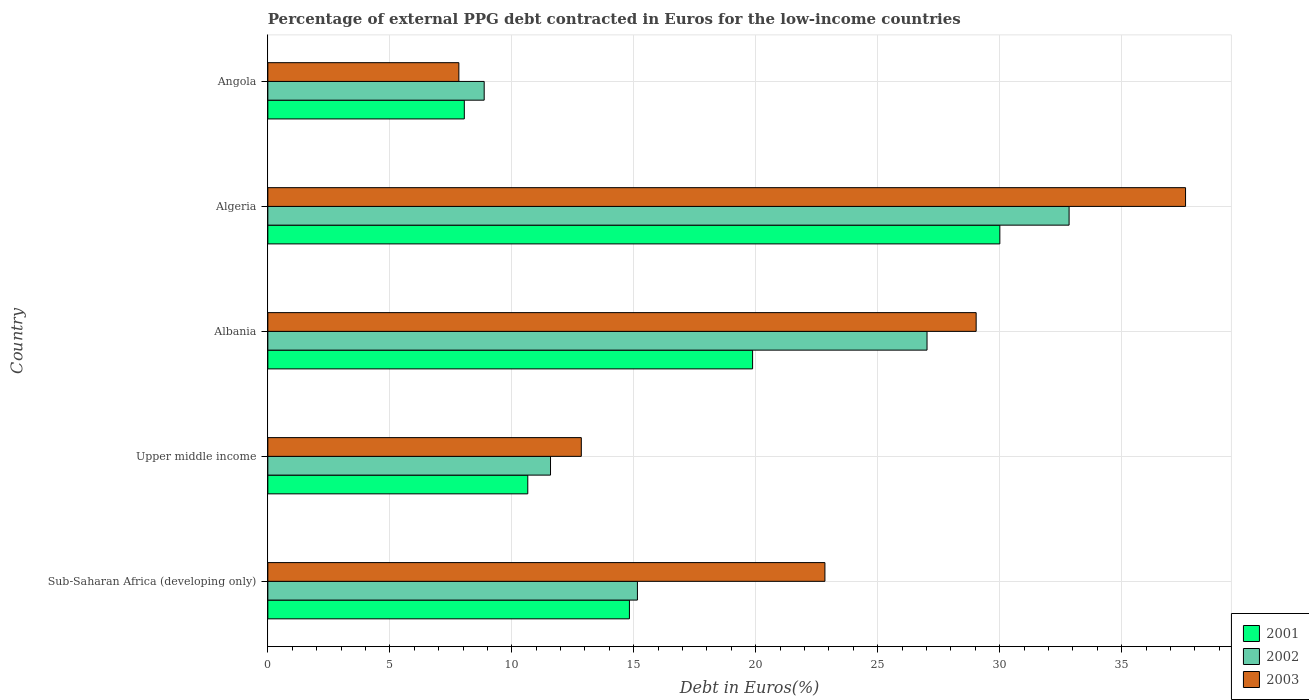Are the number of bars on each tick of the Y-axis equal?
Make the answer very short. Yes. How many bars are there on the 1st tick from the top?
Provide a short and direct response. 3. How many bars are there on the 5th tick from the bottom?
Keep it short and to the point. 3. What is the label of the 4th group of bars from the top?
Your answer should be very brief. Upper middle income. In how many cases, is the number of bars for a given country not equal to the number of legend labels?
Your answer should be very brief. 0. What is the percentage of external PPG debt contracted in Euros in 2003 in Algeria?
Provide a succinct answer. 37.62. Across all countries, what is the maximum percentage of external PPG debt contracted in Euros in 2001?
Keep it short and to the point. 30.01. Across all countries, what is the minimum percentage of external PPG debt contracted in Euros in 2002?
Provide a succinct answer. 8.87. In which country was the percentage of external PPG debt contracted in Euros in 2001 maximum?
Give a very brief answer. Algeria. In which country was the percentage of external PPG debt contracted in Euros in 2003 minimum?
Your answer should be compact. Angola. What is the total percentage of external PPG debt contracted in Euros in 2003 in the graph?
Provide a succinct answer. 110.17. What is the difference between the percentage of external PPG debt contracted in Euros in 2003 in Algeria and that in Angola?
Your answer should be compact. 29.79. What is the difference between the percentage of external PPG debt contracted in Euros in 2002 in Albania and the percentage of external PPG debt contracted in Euros in 2001 in Sub-Saharan Africa (developing only)?
Keep it short and to the point. 12.2. What is the average percentage of external PPG debt contracted in Euros in 2003 per country?
Provide a short and direct response. 22.03. What is the difference between the percentage of external PPG debt contracted in Euros in 2003 and percentage of external PPG debt contracted in Euros in 2002 in Albania?
Your response must be concise. 2.01. In how many countries, is the percentage of external PPG debt contracted in Euros in 2003 greater than 12 %?
Your answer should be compact. 4. What is the ratio of the percentage of external PPG debt contracted in Euros in 2001 in Algeria to that in Upper middle income?
Offer a very short reply. 2.82. Is the difference between the percentage of external PPG debt contracted in Euros in 2003 in Albania and Upper middle income greater than the difference between the percentage of external PPG debt contracted in Euros in 2002 in Albania and Upper middle income?
Make the answer very short. Yes. What is the difference between the highest and the second highest percentage of external PPG debt contracted in Euros in 2002?
Offer a very short reply. 5.82. What is the difference between the highest and the lowest percentage of external PPG debt contracted in Euros in 2003?
Offer a terse response. 29.79. In how many countries, is the percentage of external PPG debt contracted in Euros in 2002 greater than the average percentage of external PPG debt contracted in Euros in 2002 taken over all countries?
Make the answer very short. 2. What does the 3rd bar from the top in Angola represents?
Make the answer very short. 2001. What does the 1st bar from the bottom in Angola represents?
Keep it short and to the point. 2001. Is it the case that in every country, the sum of the percentage of external PPG debt contracted in Euros in 2003 and percentage of external PPG debt contracted in Euros in 2001 is greater than the percentage of external PPG debt contracted in Euros in 2002?
Offer a terse response. Yes. How many bars are there?
Ensure brevity in your answer.  15. Are all the bars in the graph horizontal?
Keep it short and to the point. Yes. How many countries are there in the graph?
Your answer should be compact. 5. Does the graph contain grids?
Your answer should be very brief. Yes. Where does the legend appear in the graph?
Your response must be concise. Bottom right. What is the title of the graph?
Make the answer very short. Percentage of external PPG debt contracted in Euros for the low-income countries. Does "1986" appear as one of the legend labels in the graph?
Your answer should be very brief. No. What is the label or title of the X-axis?
Provide a succinct answer. Debt in Euros(%). What is the Debt in Euros(%) in 2001 in Sub-Saharan Africa (developing only)?
Ensure brevity in your answer.  14.82. What is the Debt in Euros(%) of 2002 in Sub-Saharan Africa (developing only)?
Provide a short and direct response. 15.15. What is the Debt in Euros(%) of 2003 in Sub-Saharan Africa (developing only)?
Provide a succinct answer. 22.84. What is the Debt in Euros(%) of 2001 in Upper middle income?
Offer a very short reply. 10.66. What is the Debt in Euros(%) of 2002 in Upper middle income?
Make the answer very short. 11.59. What is the Debt in Euros(%) in 2003 in Upper middle income?
Provide a short and direct response. 12.85. What is the Debt in Euros(%) in 2001 in Albania?
Your response must be concise. 19.87. What is the Debt in Euros(%) in 2002 in Albania?
Provide a succinct answer. 27.02. What is the Debt in Euros(%) of 2003 in Albania?
Offer a terse response. 29.04. What is the Debt in Euros(%) of 2001 in Algeria?
Your answer should be compact. 30.01. What is the Debt in Euros(%) in 2002 in Algeria?
Ensure brevity in your answer.  32.85. What is the Debt in Euros(%) of 2003 in Algeria?
Offer a terse response. 37.62. What is the Debt in Euros(%) in 2001 in Angola?
Keep it short and to the point. 8.05. What is the Debt in Euros(%) in 2002 in Angola?
Your answer should be very brief. 8.87. What is the Debt in Euros(%) of 2003 in Angola?
Offer a very short reply. 7.83. Across all countries, what is the maximum Debt in Euros(%) in 2001?
Offer a very short reply. 30.01. Across all countries, what is the maximum Debt in Euros(%) of 2002?
Provide a succinct answer. 32.85. Across all countries, what is the maximum Debt in Euros(%) of 2003?
Your answer should be compact. 37.62. Across all countries, what is the minimum Debt in Euros(%) of 2001?
Provide a succinct answer. 8.05. Across all countries, what is the minimum Debt in Euros(%) in 2002?
Keep it short and to the point. 8.87. Across all countries, what is the minimum Debt in Euros(%) of 2003?
Your response must be concise. 7.83. What is the total Debt in Euros(%) of 2001 in the graph?
Your answer should be compact. 83.41. What is the total Debt in Euros(%) of 2002 in the graph?
Keep it short and to the point. 95.47. What is the total Debt in Euros(%) in 2003 in the graph?
Provide a short and direct response. 110.17. What is the difference between the Debt in Euros(%) of 2001 in Sub-Saharan Africa (developing only) and that in Upper middle income?
Provide a succinct answer. 4.17. What is the difference between the Debt in Euros(%) in 2002 in Sub-Saharan Africa (developing only) and that in Upper middle income?
Provide a succinct answer. 3.56. What is the difference between the Debt in Euros(%) in 2003 in Sub-Saharan Africa (developing only) and that in Upper middle income?
Provide a succinct answer. 9.99. What is the difference between the Debt in Euros(%) of 2001 in Sub-Saharan Africa (developing only) and that in Albania?
Offer a terse response. -5.05. What is the difference between the Debt in Euros(%) of 2002 in Sub-Saharan Africa (developing only) and that in Albania?
Give a very brief answer. -11.87. What is the difference between the Debt in Euros(%) in 2003 in Sub-Saharan Africa (developing only) and that in Albania?
Provide a succinct answer. -6.2. What is the difference between the Debt in Euros(%) of 2001 in Sub-Saharan Africa (developing only) and that in Algeria?
Keep it short and to the point. -15.18. What is the difference between the Debt in Euros(%) of 2002 in Sub-Saharan Africa (developing only) and that in Algeria?
Ensure brevity in your answer.  -17.7. What is the difference between the Debt in Euros(%) in 2003 in Sub-Saharan Africa (developing only) and that in Algeria?
Ensure brevity in your answer.  -14.78. What is the difference between the Debt in Euros(%) of 2001 in Sub-Saharan Africa (developing only) and that in Angola?
Keep it short and to the point. 6.77. What is the difference between the Debt in Euros(%) in 2002 in Sub-Saharan Africa (developing only) and that in Angola?
Your answer should be very brief. 6.28. What is the difference between the Debt in Euros(%) in 2003 in Sub-Saharan Africa (developing only) and that in Angola?
Your answer should be very brief. 15.01. What is the difference between the Debt in Euros(%) in 2001 in Upper middle income and that in Albania?
Provide a short and direct response. -9.22. What is the difference between the Debt in Euros(%) in 2002 in Upper middle income and that in Albania?
Offer a terse response. -15.43. What is the difference between the Debt in Euros(%) in 2003 in Upper middle income and that in Albania?
Provide a succinct answer. -16.19. What is the difference between the Debt in Euros(%) of 2001 in Upper middle income and that in Algeria?
Provide a succinct answer. -19.35. What is the difference between the Debt in Euros(%) in 2002 in Upper middle income and that in Algeria?
Keep it short and to the point. -21.26. What is the difference between the Debt in Euros(%) of 2003 in Upper middle income and that in Algeria?
Provide a succinct answer. -24.77. What is the difference between the Debt in Euros(%) in 2001 in Upper middle income and that in Angola?
Your answer should be compact. 2.6. What is the difference between the Debt in Euros(%) of 2002 in Upper middle income and that in Angola?
Offer a very short reply. 2.72. What is the difference between the Debt in Euros(%) of 2003 in Upper middle income and that in Angola?
Make the answer very short. 5.02. What is the difference between the Debt in Euros(%) in 2001 in Albania and that in Algeria?
Your answer should be very brief. -10.14. What is the difference between the Debt in Euros(%) in 2002 in Albania and that in Algeria?
Provide a succinct answer. -5.82. What is the difference between the Debt in Euros(%) in 2003 in Albania and that in Algeria?
Your response must be concise. -8.58. What is the difference between the Debt in Euros(%) of 2001 in Albania and that in Angola?
Provide a short and direct response. 11.82. What is the difference between the Debt in Euros(%) of 2002 in Albania and that in Angola?
Provide a short and direct response. 18.15. What is the difference between the Debt in Euros(%) in 2003 in Albania and that in Angola?
Provide a succinct answer. 21.21. What is the difference between the Debt in Euros(%) of 2001 in Algeria and that in Angola?
Give a very brief answer. 21.95. What is the difference between the Debt in Euros(%) in 2002 in Algeria and that in Angola?
Give a very brief answer. 23.98. What is the difference between the Debt in Euros(%) of 2003 in Algeria and that in Angola?
Offer a terse response. 29.79. What is the difference between the Debt in Euros(%) of 2001 in Sub-Saharan Africa (developing only) and the Debt in Euros(%) of 2002 in Upper middle income?
Keep it short and to the point. 3.23. What is the difference between the Debt in Euros(%) in 2001 in Sub-Saharan Africa (developing only) and the Debt in Euros(%) in 2003 in Upper middle income?
Make the answer very short. 1.97. What is the difference between the Debt in Euros(%) in 2002 in Sub-Saharan Africa (developing only) and the Debt in Euros(%) in 2003 in Upper middle income?
Your answer should be very brief. 2.3. What is the difference between the Debt in Euros(%) in 2001 in Sub-Saharan Africa (developing only) and the Debt in Euros(%) in 2002 in Albania?
Keep it short and to the point. -12.2. What is the difference between the Debt in Euros(%) of 2001 in Sub-Saharan Africa (developing only) and the Debt in Euros(%) of 2003 in Albania?
Your response must be concise. -14.21. What is the difference between the Debt in Euros(%) of 2002 in Sub-Saharan Africa (developing only) and the Debt in Euros(%) of 2003 in Albania?
Provide a short and direct response. -13.89. What is the difference between the Debt in Euros(%) in 2001 in Sub-Saharan Africa (developing only) and the Debt in Euros(%) in 2002 in Algeria?
Offer a terse response. -18.02. What is the difference between the Debt in Euros(%) in 2001 in Sub-Saharan Africa (developing only) and the Debt in Euros(%) in 2003 in Algeria?
Provide a succinct answer. -22.8. What is the difference between the Debt in Euros(%) of 2002 in Sub-Saharan Africa (developing only) and the Debt in Euros(%) of 2003 in Algeria?
Give a very brief answer. -22.47. What is the difference between the Debt in Euros(%) in 2001 in Sub-Saharan Africa (developing only) and the Debt in Euros(%) in 2002 in Angola?
Your answer should be compact. 5.95. What is the difference between the Debt in Euros(%) in 2001 in Sub-Saharan Africa (developing only) and the Debt in Euros(%) in 2003 in Angola?
Ensure brevity in your answer.  6.99. What is the difference between the Debt in Euros(%) in 2002 in Sub-Saharan Africa (developing only) and the Debt in Euros(%) in 2003 in Angola?
Provide a succinct answer. 7.32. What is the difference between the Debt in Euros(%) of 2001 in Upper middle income and the Debt in Euros(%) of 2002 in Albania?
Ensure brevity in your answer.  -16.37. What is the difference between the Debt in Euros(%) of 2001 in Upper middle income and the Debt in Euros(%) of 2003 in Albania?
Your response must be concise. -18.38. What is the difference between the Debt in Euros(%) in 2002 in Upper middle income and the Debt in Euros(%) in 2003 in Albania?
Provide a succinct answer. -17.45. What is the difference between the Debt in Euros(%) of 2001 in Upper middle income and the Debt in Euros(%) of 2002 in Algeria?
Offer a very short reply. -22.19. What is the difference between the Debt in Euros(%) in 2001 in Upper middle income and the Debt in Euros(%) in 2003 in Algeria?
Your answer should be very brief. -26.96. What is the difference between the Debt in Euros(%) of 2002 in Upper middle income and the Debt in Euros(%) of 2003 in Algeria?
Provide a short and direct response. -26.03. What is the difference between the Debt in Euros(%) of 2001 in Upper middle income and the Debt in Euros(%) of 2002 in Angola?
Provide a succinct answer. 1.79. What is the difference between the Debt in Euros(%) in 2001 in Upper middle income and the Debt in Euros(%) in 2003 in Angola?
Keep it short and to the point. 2.83. What is the difference between the Debt in Euros(%) of 2002 in Upper middle income and the Debt in Euros(%) of 2003 in Angola?
Provide a short and direct response. 3.76. What is the difference between the Debt in Euros(%) in 2001 in Albania and the Debt in Euros(%) in 2002 in Algeria?
Make the answer very short. -12.97. What is the difference between the Debt in Euros(%) in 2001 in Albania and the Debt in Euros(%) in 2003 in Algeria?
Make the answer very short. -17.75. What is the difference between the Debt in Euros(%) of 2002 in Albania and the Debt in Euros(%) of 2003 in Algeria?
Offer a terse response. -10.6. What is the difference between the Debt in Euros(%) in 2001 in Albania and the Debt in Euros(%) in 2002 in Angola?
Offer a terse response. 11. What is the difference between the Debt in Euros(%) in 2001 in Albania and the Debt in Euros(%) in 2003 in Angola?
Give a very brief answer. 12.04. What is the difference between the Debt in Euros(%) in 2002 in Albania and the Debt in Euros(%) in 2003 in Angola?
Your answer should be compact. 19.19. What is the difference between the Debt in Euros(%) in 2001 in Algeria and the Debt in Euros(%) in 2002 in Angola?
Your response must be concise. 21.14. What is the difference between the Debt in Euros(%) in 2001 in Algeria and the Debt in Euros(%) in 2003 in Angola?
Your answer should be compact. 22.18. What is the difference between the Debt in Euros(%) of 2002 in Algeria and the Debt in Euros(%) of 2003 in Angola?
Offer a terse response. 25.02. What is the average Debt in Euros(%) of 2001 per country?
Your response must be concise. 16.68. What is the average Debt in Euros(%) in 2002 per country?
Your response must be concise. 19.09. What is the average Debt in Euros(%) in 2003 per country?
Offer a terse response. 22.03. What is the difference between the Debt in Euros(%) of 2001 and Debt in Euros(%) of 2002 in Sub-Saharan Africa (developing only)?
Keep it short and to the point. -0.33. What is the difference between the Debt in Euros(%) of 2001 and Debt in Euros(%) of 2003 in Sub-Saharan Africa (developing only)?
Make the answer very short. -8.01. What is the difference between the Debt in Euros(%) of 2002 and Debt in Euros(%) of 2003 in Sub-Saharan Africa (developing only)?
Ensure brevity in your answer.  -7.69. What is the difference between the Debt in Euros(%) in 2001 and Debt in Euros(%) in 2002 in Upper middle income?
Give a very brief answer. -0.93. What is the difference between the Debt in Euros(%) of 2001 and Debt in Euros(%) of 2003 in Upper middle income?
Offer a terse response. -2.19. What is the difference between the Debt in Euros(%) in 2002 and Debt in Euros(%) in 2003 in Upper middle income?
Your answer should be compact. -1.26. What is the difference between the Debt in Euros(%) of 2001 and Debt in Euros(%) of 2002 in Albania?
Offer a terse response. -7.15. What is the difference between the Debt in Euros(%) in 2001 and Debt in Euros(%) in 2003 in Albania?
Keep it short and to the point. -9.16. What is the difference between the Debt in Euros(%) in 2002 and Debt in Euros(%) in 2003 in Albania?
Your answer should be compact. -2.01. What is the difference between the Debt in Euros(%) in 2001 and Debt in Euros(%) in 2002 in Algeria?
Make the answer very short. -2.84. What is the difference between the Debt in Euros(%) in 2001 and Debt in Euros(%) in 2003 in Algeria?
Make the answer very short. -7.61. What is the difference between the Debt in Euros(%) of 2002 and Debt in Euros(%) of 2003 in Algeria?
Offer a terse response. -4.77. What is the difference between the Debt in Euros(%) of 2001 and Debt in Euros(%) of 2002 in Angola?
Offer a terse response. -0.81. What is the difference between the Debt in Euros(%) in 2001 and Debt in Euros(%) in 2003 in Angola?
Keep it short and to the point. 0.22. What is the difference between the Debt in Euros(%) in 2002 and Debt in Euros(%) in 2003 in Angola?
Offer a terse response. 1.04. What is the ratio of the Debt in Euros(%) of 2001 in Sub-Saharan Africa (developing only) to that in Upper middle income?
Offer a terse response. 1.39. What is the ratio of the Debt in Euros(%) of 2002 in Sub-Saharan Africa (developing only) to that in Upper middle income?
Your answer should be very brief. 1.31. What is the ratio of the Debt in Euros(%) in 2003 in Sub-Saharan Africa (developing only) to that in Upper middle income?
Your answer should be compact. 1.78. What is the ratio of the Debt in Euros(%) in 2001 in Sub-Saharan Africa (developing only) to that in Albania?
Your response must be concise. 0.75. What is the ratio of the Debt in Euros(%) in 2002 in Sub-Saharan Africa (developing only) to that in Albania?
Your answer should be very brief. 0.56. What is the ratio of the Debt in Euros(%) in 2003 in Sub-Saharan Africa (developing only) to that in Albania?
Provide a succinct answer. 0.79. What is the ratio of the Debt in Euros(%) in 2001 in Sub-Saharan Africa (developing only) to that in Algeria?
Provide a short and direct response. 0.49. What is the ratio of the Debt in Euros(%) of 2002 in Sub-Saharan Africa (developing only) to that in Algeria?
Provide a short and direct response. 0.46. What is the ratio of the Debt in Euros(%) in 2003 in Sub-Saharan Africa (developing only) to that in Algeria?
Make the answer very short. 0.61. What is the ratio of the Debt in Euros(%) in 2001 in Sub-Saharan Africa (developing only) to that in Angola?
Provide a succinct answer. 1.84. What is the ratio of the Debt in Euros(%) of 2002 in Sub-Saharan Africa (developing only) to that in Angola?
Provide a short and direct response. 1.71. What is the ratio of the Debt in Euros(%) of 2003 in Sub-Saharan Africa (developing only) to that in Angola?
Your response must be concise. 2.92. What is the ratio of the Debt in Euros(%) in 2001 in Upper middle income to that in Albania?
Your answer should be very brief. 0.54. What is the ratio of the Debt in Euros(%) of 2002 in Upper middle income to that in Albania?
Provide a succinct answer. 0.43. What is the ratio of the Debt in Euros(%) of 2003 in Upper middle income to that in Albania?
Your answer should be very brief. 0.44. What is the ratio of the Debt in Euros(%) in 2001 in Upper middle income to that in Algeria?
Provide a succinct answer. 0.36. What is the ratio of the Debt in Euros(%) of 2002 in Upper middle income to that in Algeria?
Offer a terse response. 0.35. What is the ratio of the Debt in Euros(%) in 2003 in Upper middle income to that in Algeria?
Provide a short and direct response. 0.34. What is the ratio of the Debt in Euros(%) in 2001 in Upper middle income to that in Angola?
Keep it short and to the point. 1.32. What is the ratio of the Debt in Euros(%) in 2002 in Upper middle income to that in Angola?
Your answer should be compact. 1.31. What is the ratio of the Debt in Euros(%) of 2003 in Upper middle income to that in Angola?
Offer a very short reply. 1.64. What is the ratio of the Debt in Euros(%) in 2001 in Albania to that in Algeria?
Your answer should be very brief. 0.66. What is the ratio of the Debt in Euros(%) in 2002 in Albania to that in Algeria?
Provide a succinct answer. 0.82. What is the ratio of the Debt in Euros(%) in 2003 in Albania to that in Algeria?
Make the answer very short. 0.77. What is the ratio of the Debt in Euros(%) in 2001 in Albania to that in Angola?
Provide a short and direct response. 2.47. What is the ratio of the Debt in Euros(%) of 2002 in Albania to that in Angola?
Give a very brief answer. 3.05. What is the ratio of the Debt in Euros(%) in 2003 in Albania to that in Angola?
Your answer should be very brief. 3.71. What is the ratio of the Debt in Euros(%) in 2001 in Algeria to that in Angola?
Offer a very short reply. 3.73. What is the ratio of the Debt in Euros(%) in 2002 in Algeria to that in Angola?
Ensure brevity in your answer.  3.7. What is the ratio of the Debt in Euros(%) in 2003 in Algeria to that in Angola?
Provide a succinct answer. 4.8. What is the difference between the highest and the second highest Debt in Euros(%) of 2001?
Your answer should be compact. 10.14. What is the difference between the highest and the second highest Debt in Euros(%) of 2002?
Your response must be concise. 5.82. What is the difference between the highest and the second highest Debt in Euros(%) of 2003?
Your answer should be compact. 8.58. What is the difference between the highest and the lowest Debt in Euros(%) of 2001?
Keep it short and to the point. 21.95. What is the difference between the highest and the lowest Debt in Euros(%) of 2002?
Your answer should be very brief. 23.98. What is the difference between the highest and the lowest Debt in Euros(%) in 2003?
Provide a short and direct response. 29.79. 